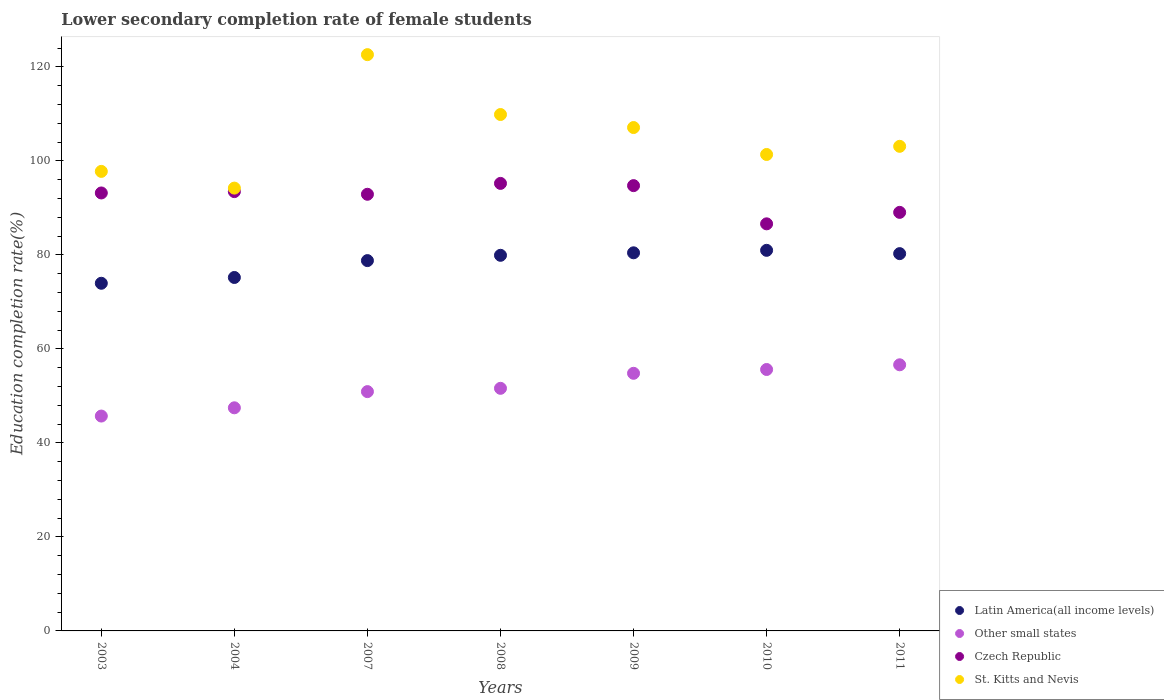What is the lower secondary completion rate of female students in Latin America(all income levels) in 2010?
Your answer should be compact. 80.98. Across all years, what is the maximum lower secondary completion rate of female students in Czech Republic?
Offer a terse response. 95.22. Across all years, what is the minimum lower secondary completion rate of female students in St. Kitts and Nevis?
Your answer should be compact. 94.22. In which year was the lower secondary completion rate of female students in St. Kitts and Nevis maximum?
Offer a very short reply. 2007. In which year was the lower secondary completion rate of female students in Czech Republic minimum?
Offer a terse response. 2010. What is the total lower secondary completion rate of female students in Latin America(all income levels) in the graph?
Your answer should be very brief. 549.61. What is the difference between the lower secondary completion rate of female students in Other small states in 2004 and that in 2011?
Your answer should be very brief. -9.15. What is the difference between the lower secondary completion rate of female students in Other small states in 2007 and the lower secondary completion rate of female students in St. Kitts and Nevis in 2009?
Your answer should be very brief. -56.19. What is the average lower secondary completion rate of female students in Latin America(all income levels) per year?
Offer a very short reply. 78.52. In the year 2003, what is the difference between the lower secondary completion rate of female students in Other small states and lower secondary completion rate of female students in St. Kitts and Nevis?
Your answer should be very brief. -52.06. What is the ratio of the lower secondary completion rate of female students in Other small states in 2004 to that in 2009?
Your answer should be very brief. 0.87. Is the lower secondary completion rate of female students in Czech Republic in 2003 less than that in 2011?
Offer a very short reply. No. Is the difference between the lower secondary completion rate of female students in Other small states in 2007 and 2010 greater than the difference between the lower secondary completion rate of female students in St. Kitts and Nevis in 2007 and 2010?
Offer a very short reply. No. What is the difference between the highest and the second highest lower secondary completion rate of female students in St. Kitts and Nevis?
Give a very brief answer. 12.74. What is the difference between the highest and the lowest lower secondary completion rate of female students in Czech Republic?
Make the answer very short. 8.6. In how many years, is the lower secondary completion rate of female students in St. Kitts and Nevis greater than the average lower secondary completion rate of female students in St. Kitts and Nevis taken over all years?
Provide a short and direct response. 3. Is it the case that in every year, the sum of the lower secondary completion rate of female students in St. Kitts and Nevis and lower secondary completion rate of female students in Latin America(all income levels)  is greater than the sum of lower secondary completion rate of female students in Other small states and lower secondary completion rate of female students in Czech Republic?
Your response must be concise. No. Does the lower secondary completion rate of female students in Other small states monotonically increase over the years?
Offer a terse response. Yes. Is the lower secondary completion rate of female students in Other small states strictly less than the lower secondary completion rate of female students in St. Kitts and Nevis over the years?
Keep it short and to the point. Yes. How many dotlines are there?
Offer a terse response. 4. Are the values on the major ticks of Y-axis written in scientific E-notation?
Give a very brief answer. No. Does the graph contain grids?
Your response must be concise. No. How many legend labels are there?
Provide a succinct answer. 4. What is the title of the graph?
Your answer should be very brief. Lower secondary completion rate of female students. Does "Ghana" appear as one of the legend labels in the graph?
Your response must be concise. No. What is the label or title of the Y-axis?
Provide a short and direct response. Education completion rate(%). What is the Education completion rate(%) in Latin America(all income levels) in 2003?
Make the answer very short. 73.97. What is the Education completion rate(%) in Other small states in 2003?
Your answer should be compact. 45.72. What is the Education completion rate(%) in Czech Republic in 2003?
Your response must be concise. 93.19. What is the Education completion rate(%) in St. Kitts and Nevis in 2003?
Offer a very short reply. 97.78. What is the Education completion rate(%) in Latin America(all income levels) in 2004?
Your response must be concise. 75.2. What is the Education completion rate(%) of Other small states in 2004?
Your answer should be compact. 47.47. What is the Education completion rate(%) in Czech Republic in 2004?
Provide a short and direct response. 93.48. What is the Education completion rate(%) of St. Kitts and Nevis in 2004?
Your response must be concise. 94.22. What is the Education completion rate(%) in Latin America(all income levels) in 2007?
Give a very brief answer. 78.8. What is the Education completion rate(%) in Other small states in 2007?
Keep it short and to the point. 50.92. What is the Education completion rate(%) in Czech Republic in 2007?
Make the answer very short. 92.91. What is the Education completion rate(%) of St. Kitts and Nevis in 2007?
Give a very brief answer. 122.62. What is the Education completion rate(%) of Latin America(all income levels) in 2008?
Provide a short and direct response. 79.92. What is the Education completion rate(%) in Other small states in 2008?
Your response must be concise. 51.62. What is the Education completion rate(%) in Czech Republic in 2008?
Give a very brief answer. 95.22. What is the Education completion rate(%) of St. Kitts and Nevis in 2008?
Keep it short and to the point. 109.88. What is the Education completion rate(%) of Latin America(all income levels) in 2009?
Offer a very short reply. 80.45. What is the Education completion rate(%) in Other small states in 2009?
Make the answer very short. 54.82. What is the Education completion rate(%) in Czech Republic in 2009?
Offer a very short reply. 94.75. What is the Education completion rate(%) in St. Kitts and Nevis in 2009?
Your answer should be very brief. 107.11. What is the Education completion rate(%) of Latin America(all income levels) in 2010?
Ensure brevity in your answer.  80.98. What is the Education completion rate(%) of Other small states in 2010?
Make the answer very short. 55.63. What is the Education completion rate(%) in Czech Republic in 2010?
Offer a very short reply. 86.62. What is the Education completion rate(%) of St. Kitts and Nevis in 2010?
Your answer should be very brief. 101.38. What is the Education completion rate(%) in Latin America(all income levels) in 2011?
Your answer should be very brief. 80.28. What is the Education completion rate(%) of Other small states in 2011?
Offer a very short reply. 56.63. What is the Education completion rate(%) in Czech Republic in 2011?
Provide a succinct answer. 89.06. What is the Education completion rate(%) in St. Kitts and Nevis in 2011?
Ensure brevity in your answer.  103.11. Across all years, what is the maximum Education completion rate(%) in Latin America(all income levels)?
Your answer should be very brief. 80.98. Across all years, what is the maximum Education completion rate(%) of Other small states?
Offer a very short reply. 56.63. Across all years, what is the maximum Education completion rate(%) of Czech Republic?
Offer a very short reply. 95.22. Across all years, what is the maximum Education completion rate(%) of St. Kitts and Nevis?
Give a very brief answer. 122.62. Across all years, what is the minimum Education completion rate(%) of Latin America(all income levels)?
Keep it short and to the point. 73.97. Across all years, what is the minimum Education completion rate(%) in Other small states?
Offer a terse response. 45.72. Across all years, what is the minimum Education completion rate(%) of Czech Republic?
Provide a succinct answer. 86.62. Across all years, what is the minimum Education completion rate(%) of St. Kitts and Nevis?
Provide a succinct answer. 94.22. What is the total Education completion rate(%) in Latin America(all income levels) in the graph?
Provide a short and direct response. 549.61. What is the total Education completion rate(%) in Other small states in the graph?
Give a very brief answer. 362.8. What is the total Education completion rate(%) of Czech Republic in the graph?
Provide a short and direct response. 645.22. What is the total Education completion rate(%) of St. Kitts and Nevis in the graph?
Provide a succinct answer. 736.09. What is the difference between the Education completion rate(%) of Latin America(all income levels) in 2003 and that in 2004?
Offer a terse response. -1.23. What is the difference between the Education completion rate(%) in Other small states in 2003 and that in 2004?
Make the answer very short. -1.76. What is the difference between the Education completion rate(%) of Czech Republic in 2003 and that in 2004?
Your answer should be compact. -0.29. What is the difference between the Education completion rate(%) in St. Kitts and Nevis in 2003 and that in 2004?
Your answer should be compact. 3.56. What is the difference between the Education completion rate(%) of Latin America(all income levels) in 2003 and that in 2007?
Make the answer very short. -4.82. What is the difference between the Education completion rate(%) in Other small states in 2003 and that in 2007?
Your answer should be compact. -5.2. What is the difference between the Education completion rate(%) in Czech Republic in 2003 and that in 2007?
Keep it short and to the point. 0.28. What is the difference between the Education completion rate(%) in St. Kitts and Nevis in 2003 and that in 2007?
Your answer should be very brief. -24.84. What is the difference between the Education completion rate(%) of Latin America(all income levels) in 2003 and that in 2008?
Offer a terse response. -5.95. What is the difference between the Education completion rate(%) in Other small states in 2003 and that in 2008?
Make the answer very short. -5.9. What is the difference between the Education completion rate(%) of Czech Republic in 2003 and that in 2008?
Offer a very short reply. -2.03. What is the difference between the Education completion rate(%) of St. Kitts and Nevis in 2003 and that in 2008?
Your answer should be very brief. -12.1. What is the difference between the Education completion rate(%) of Latin America(all income levels) in 2003 and that in 2009?
Provide a succinct answer. -6.48. What is the difference between the Education completion rate(%) of Other small states in 2003 and that in 2009?
Your answer should be compact. -9.1. What is the difference between the Education completion rate(%) in Czech Republic in 2003 and that in 2009?
Provide a short and direct response. -1.56. What is the difference between the Education completion rate(%) in St. Kitts and Nevis in 2003 and that in 2009?
Ensure brevity in your answer.  -9.33. What is the difference between the Education completion rate(%) in Latin America(all income levels) in 2003 and that in 2010?
Your response must be concise. -7.01. What is the difference between the Education completion rate(%) in Other small states in 2003 and that in 2010?
Your response must be concise. -9.91. What is the difference between the Education completion rate(%) of Czech Republic in 2003 and that in 2010?
Provide a short and direct response. 6.57. What is the difference between the Education completion rate(%) of St. Kitts and Nevis in 2003 and that in 2010?
Provide a short and direct response. -3.6. What is the difference between the Education completion rate(%) in Latin America(all income levels) in 2003 and that in 2011?
Offer a terse response. -6.31. What is the difference between the Education completion rate(%) of Other small states in 2003 and that in 2011?
Give a very brief answer. -10.91. What is the difference between the Education completion rate(%) of Czech Republic in 2003 and that in 2011?
Provide a short and direct response. 4.13. What is the difference between the Education completion rate(%) of St. Kitts and Nevis in 2003 and that in 2011?
Provide a short and direct response. -5.33. What is the difference between the Education completion rate(%) of Latin America(all income levels) in 2004 and that in 2007?
Offer a terse response. -3.59. What is the difference between the Education completion rate(%) in Other small states in 2004 and that in 2007?
Give a very brief answer. -3.45. What is the difference between the Education completion rate(%) in Czech Republic in 2004 and that in 2007?
Offer a very short reply. 0.57. What is the difference between the Education completion rate(%) of St. Kitts and Nevis in 2004 and that in 2007?
Make the answer very short. -28.4. What is the difference between the Education completion rate(%) of Latin America(all income levels) in 2004 and that in 2008?
Your response must be concise. -4.72. What is the difference between the Education completion rate(%) in Other small states in 2004 and that in 2008?
Your answer should be very brief. -4.15. What is the difference between the Education completion rate(%) of Czech Republic in 2004 and that in 2008?
Provide a short and direct response. -1.75. What is the difference between the Education completion rate(%) of St. Kitts and Nevis in 2004 and that in 2008?
Ensure brevity in your answer.  -15.66. What is the difference between the Education completion rate(%) of Latin America(all income levels) in 2004 and that in 2009?
Offer a terse response. -5.25. What is the difference between the Education completion rate(%) of Other small states in 2004 and that in 2009?
Keep it short and to the point. -7.34. What is the difference between the Education completion rate(%) of Czech Republic in 2004 and that in 2009?
Ensure brevity in your answer.  -1.27. What is the difference between the Education completion rate(%) in St. Kitts and Nevis in 2004 and that in 2009?
Provide a short and direct response. -12.89. What is the difference between the Education completion rate(%) in Latin America(all income levels) in 2004 and that in 2010?
Offer a very short reply. -5.78. What is the difference between the Education completion rate(%) in Other small states in 2004 and that in 2010?
Give a very brief answer. -8.15. What is the difference between the Education completion rate(%) in Czech Republic in 2004 and that in 2010?
Your answer should be very brief. 6.86. What is the difference between the Education completion rate(%) of St. Kitts and Nevis in 2004 and that in 2010?
Ensure brevity in your answer.  -7.15. What is the difference between the Education completion rate(%) of Latin America(all income levels) in 2004 and that in 2011?
Provide a succinct answer. -5.08. What is the difference between the Education completion rate(%) of Other small states in 2004 and that in 2011?
Offer a terse response. -9.15. What is the difference between the Education completion rate(%) of Czech Republic in 2004 and that in 2011?
Provide a succinct answer. 4.42. What is the difference between the Education completion rate(%) in St. Kitts and Nevis in 2004 and that in 2011?
Your response must be concise. -8.89. What is the difference between the Education completion rate(%) in Latin America(all income levels) in 2007 and that in 2008?
Keep it short and to the point. -1.13. What is the difference between the Education completion rate(%) of Other small states in 2007 and that in 2008?
Ensure brevity in your answer.  -0.7. What is the difference between the Education completion rate(%) of Czech Republic in 2007 and that in 2008?
Your answer should be compact. -2.32. What is the difference between the Education completion rate(%) in St. Kitts and Nevis in 2007 and that in 2008?
Provide a succinct answer. 12.74. What is the difference between the Education completion rate(%) of Latin America(all income levels) in 2007 and that in 2009?
Give a very brief answer. -1.66. What is the difference between the Education completion rate(%) in Other small states in 2007 and that in 2009?
Make the answer very short. -3.9. What is the difference between the Education completion rate(%) of Czech Republic in 2007 and that in 2009?
Give a very brief answer. -1.84. What is the difference between the Education completion rate(%) of St. Kitts and Nevis in 2007 and that in 2009?
Keep it short and to the point. 15.51. What is the difference between the Education completion rate(%) in Latin America(all income levels) in 2007 and that in 2010?
Provide a short and direct response. -2.19. What is the difference between the Education completion rate(%) of Other small states in 2007 and that in 2010?
Provide a short and direct response. -4.71. What is the difference between the Education completion rate(%) in Czech Republic in 2007 and that in 2010?
Your answer should be compact. 6.29. What is the difference between the Education completion rate(%) in St. Kitts and Nevis in 2007 and that in 2010?
Provide a short and direct response. 21.24. What is the difference between the Education completion rate(%) in Latin America(all income levels) in 2007 and that in 2011?
Offer a very short reply. -1.48. What is the difference between the Education completion rate(%) in Other small states in 2007 and that in 2011?
Your response must be concise. -5.71. What is the difference between the Education completion rate(%) in Czech Republic in 2007 and that in 2011?
Offer a very short reply. 3.85. What is the difference between the Education completion rate(%) of St. Kitts and Nevis in 2007 and that in 2011?
Your response must be concise. 19.51. What is the difference between the Education completion rate(%) in Latin America(all income levels) in 2008 and that in 2009?
Ensure brevity in your answer.  -0.53. What is the difference between the Education completion rate(%) of Other small states in 2008 and that in 2009?
Provide a short and direct response. -3.2. What is the difference between the Education completion rate(%) in Czech Republic in 2008 and that in 2009?
Provide a short and direct response. 0.47. What is the difference between the Education completion rate(%) of St. Kitts and Nevis in 2008 and that in 2009?
Your answer should be very brief. 2.77. What is the difference between the Education completion rate(%) in Latin America(all income levels) in 2008 and that in 2010?
Your answer should be compact. -1.06. What is the difference between the Education completion rate(%) in Other small states in 2008 and that in 2010?
Your response must be concise. -4.01. What is the difference between the Education completion rate(%) in Czech Republic in 2008 and that in 2010?
Provide a succinct answer. 8.6. What is the difference between the Education completion rate(%) in St. Kitts and Nevis in 2008 and that in 2010?
Ensure brevity in your answer.  8.5. What is the difference between the Education completion rate(%) of Latin America(all income levels) in 2008 and that in 2011?
Give a very brief answer. -0.36. What is the difference between the Education completion rate(%) in Other small states in 2008 and that in 2011?
Ensure brevity in your answer.  -5.01. What is the difference between the Education completion rate(%) in Czech Republic in 2008 and that in 2011?
Your response must be concise. 6.16. What is the difference between the Education completion rate(%) of St. Kitts and Nevis in 2008 and that in 2011?
Offer a very short reply. 6.77. What is the difference between the Education completion rate(%) of Latin America(all income levels) in 2009 and that in 2010?
Your response must be concise. -0.53. What is the difference between the Education completion rate(%) of Other small states in 2009 and that in 2010?
Provide a succinct answer. -0.81. What is the difference between the Education completion rate(%) of Czech Republic in 2009 and that in 2010?
Provide a succinct answer. 8.13. What is the difference between the Education completion rate(%) of St. Kitts and Nevis in 2009 and that in 2010?
Your response must be concise. 5.73. What is the difference between the Education completion rate(%) of Latin America(all income levels) in 2009 and that in 2011?
Make the answer very short. 0.17. What is the difference between the Education completion rate(%) of Other small states in 2009 and that in 2011?
Provide a succinct answer. -1.81. What is the difference between the Education completion rate(%) of Czech Republic in 2009 and that in 2011?
Your answer should be compact. 5.69. What is the difference between the Education completion rate(%) in St. Kitts and Nevis in 2009 and that in 2011?
Your answer should be compact. 4. What is the difference between the Education completion rate(%) in Latin America(all income levels) in 2010 and that in 2011?
Provide a succinct answer. 0.7. What is the difference between the Education completion rate(%) of Other small states in 2010 and that in 2011?
Your answer should be very brief. -1. What is the difference between the Education completion rate(%) in Czech Republic in 2010 and that in 2011?
Offer a terse response. -2.44. What is the difference between the Education completion rate(%) in St. Kitts and Nevis in 2010 and that in 2011?
Offer a terse response. -1.74. What is the difference between the Education completion rate(%) of Latin America(all income levels) in 2003 and the Education completion rate(%) of Other small states in 2004?
Make the answer very short. 26.5. What is the difference between the Education completion rate(%) of Latin America(all income levels) in 2003 and the Education completion rate(%) of Czech Republic in 2004?
Offer a terse response. -19.5. What is the difference between the Education completion rate(%) of Latin America(all income levels) in 2003 and the Education completion rate(%) of St. Kitts and Nevis in 2004?
Ensure brevity in your answer.  -20.25. What is the difference between the Education completion rate(%) in Other small states in 2003 and the Education completion rate(%) in Czech Republic in 2004?
Give a very brief answer. -47.76. What is the difference between the Education completion rate(%) of Other small states in 2003 and the Education completion rate(%) of St. Kitts and Nevis in 2004?
Your answer should be very brief. -48.5. What is the difference between the Education completion rate(%) of Czech Republic in 2003 and the Education completion rate(%) of St. Kitts and Nevis in 2004?
Your answer should be very brief. -1.03. What is the difference between the Education completion rate(%) of Latin America(all income levels) in 2003 and the Education completion rate(%) of Other small states in 2007?
Offer a very short reply. 23.05. What is the difference between the Education completion rate(%) in Latin America(all income levels) in 2003 and the Education completion rate(%) in Czech Republic in 2007?
Your answer should be compact. -18.94. What is the difference between the Education completion rate(%) of Latin America(all income levels) in 2003 and the Education completion rate(%) of St. Kitts and Nevis in 2007?
Offer a very short reply. -48.65. What is the difference between the Education completion rate(%) of Other small states in 2003 and the Education completion rate(%) of Czech Republic in 2007?
Give a very brief answer. -47.19. What is the difference between the Education completion rate(%) of Other small states in 2003 and the Education completion rate(%) of St. Kitts and Nevis in 2007?
Your answer should be very brief. -76.9. What is the difference between the Education completion rate(%) in Czech Republic in 2003 and the Education completion rate(%) in St. Kitts and Nevis in 2007?
Keep it short and to the point. -29.43. What is the difference between the Education completion rate(%) of Latin America(all income levels) in 2003 and the Education completion rate(%) of Other small states in 2008?
Your answer should be compact. 22.35. What is the difference between the Education completion rate(%) in Latin America(all income levels) in 2003 and the Education completion rate(%) in Czech Republic in 2008?
Offer a very short reply. -21.25. What is the difference between the Education completion rate(%) of Latin America(all income levels) in 2003 and the Education completion rate(%) of St. Kitts and Nevis in 2008?
Give a very brief answer. -35.91. What is the difference between the Education completion rate(%) in Other small states in 2003 and the Education completion rate(%) in Czech Republic in 2008?
Keep it short and to the point. -49.5. What is the difference between the Education completion rate(%) in Other small states in 2003 and the Education completion rate(%) in St. Kitts and Nevis in 2008?
Provide a short and direct response. -64.16. What is the difference between the Education completion rate(%) in Czech Republic in 2003 and the Education completion rate(%) in St. Kitts and Nevis in 2008?
Ensure brevity in your answer.  -16.69. What is the difference between the Education completion rate(%) of Latin America(all income levels) in 2003 and the Education completion rate(%) of Other small states in 2009?
Provide a succinct answer. 19.16. What is the difference between the Education completion rate(%) in Latin America(all income levels) in 2003 and the Education completion rate(%) in Czech Republic in 2009?
Offer a very short reply. -20.78. What is the difference between the Education completion rate(%) of Latin America(all income levels) in 2003 and the Education completion rate(%) of St. Kitts and Nevis in 2009?
Your answer should be very brief. -33.14. What is the difference between the Education completion rate(%) of Other small states in 2003 and the Education completion rate(%) of Czech Republic in 2009?
Offer a very short reply. -49.03. What is the difference between the Education completion rate(%) of Other small states in 2003 and the Education completion rate(%) of St. Kitts and Nevis in 2009?
Provide a succinct answer. -61.39. What is the difference between the Education completion rate(%) of Czech Republic in 2003 and the Education completion rate(%) of St. Kitts and Nevis in 2009?
Make the answer very short. -13.92. What is the difference between the Education completion rate(%) of Latin America(all income levels) in 2003 and the Education completion rate(%) of Other small states in 2010?
Keep it short and to the point. 18.35. What is the difference between the Education completion rate(%) in Latin America(all income levels) in 2003 and the Education completion rate(%) in Czech Republic in 2010?
Offer a terse response. -12.65. What is the difference between the Education completion rate(%) of Latin America(all income levels) in 2003 and the Education completion rate(%) of St. Kitts and Nevis in 2010?
Your response must be concise. -27.4. What is the difference between the Education completion rate(%) in Other small states in 2003 and the Education completion rate(%) in Czech Republic in 2010?
Ensure brevity in your answer.  -40.9. What is the difference between the Education completion rate(%) of Other small states in 2003 and the Education completion rate(%) of St. Kitts and Nevis in 2010?
Ensure brevity in your answer.  -55.66. What is the difference between the Education completion rate(%) of Czech Republic in 2003 and the Education completion rate(%) of St. Kitts and Nevis in 2010?
Make the answer very short. -8.19. What is the difference between the Education completion rate(%) of Latin America(all income levels) in 2003 and the Education completion rate(%) of Other small states in 2011?
Ensure brevity in your answer.  17.35. What is the difference between the Education completion rate(%) in Latin America(all income levels) in 2003 and the Education completion rate(%) in Czech Republic in 2011?
Your answer should be compact. -15.09. What is the difference between the Education completion rate(%) of Latin America(all income levels) in 2003 and the Education completion rate(%) of St. Kitts and Nevis in 2011?
Give a very brief answer. -29.14. What is the difference between the Education completion rate(%) of Other small states in 2003 and the Education completion rate(%) of Czech Republic in 2011?
Your answer should be very brief. -43.34. What is the difference between the Education completion rate(%) of Other small states in 2003 and the Education completion rate(%) of St. Kitts and Nevis in 2011?
Offer a terse response. -57.39. What is the difference between the Education completion rate(%) of Czech Republic in 2003 and the Education completion rate(%) of St. Kitts and Nevis in 2011?
Your answer should be compact. -9.92. What is the difference between the Education completion rate(%) in Latin America(all income levels) in 2004 and the Education completion rate(%) in Other small states in 2007?
Ensure brevity in your answer.  24.28. What is the difference between the Education completion rate(%) of Latin America(all income levels) in 2004 and the Education completion rate(%) of Czech Republic in 2007?
Provide a succinct answer. -17.7. What is the difference between the Education completion rate(%) in Latin America(all income levels) in 2004 and the Education completion rate(%) in St. Kitts and Nevis in 2007?
Keep it short and to the point. -47.41. What is the difference between the Education completion rate(%) of Other small states in 2004 and the Education completion rate(%) of Czech Republic in 2007?
Give a very brief answer. -45.43. What is the difference between the Education completion rate(%) in Other small states in 2004 and the Education completion rate(%) in St. Kitts and Nevis in 2007?
Your response must be concise. -75.15. What is the difference between the Education completion rate(%) in Czech Republic in 2004 and the Education completion rate(%) in St. Kitts and Nevis in 2007?
Provide a succinct answer. -29.14. What is the difference between the Education completion rate(%) of Latin America(all income levels) in 2004 and the Education completion rate(%) of Other small states in 2008?
Your answer should be very brief. 23.58. What is the difference between the Education completion rate(%) in Latin America(all income levels) in 2004 and the Education completion rate(%) in Czech Republic in 2008?
Offer a very short reply. -20.02. What is the difference between the Education completion rate(%) of Latin America(all income levels) in 2004 and the Education completion rate(%) of St. Kitts and Nevis in 2008?
Give a very brief answer. -34.67. What is the difference between the Education completion rate(%) of Other small states in 2004 and the Education completion rate(%) of Czech Republic in 2008?
Keep it short and to the point. -47.75. What is the difference between the Education completion rate(%) of Other small states in 2004 and the Education completion rate(%) of St. Kitts and Nevis in 2008?
Offer a terse response. -62.41. What is the difference between the Education completion rate(%) in Czech Republic in 2004 and the Education completion rate(%) in St. Kitts and Nevis in 2008?
Ensure brevity in your answer.  -16.4. What is the difference between the Education completion rate(%) in Latin America(all income levels) in 2004 and the Education completion rate(%) in Other small states in 2009?
Offer a very short reply. 20.39. What is the difference between the Education completion rate(%) of Latin America(all income levels) in 2004 and the Education completion rate(%) of Czech Republic in 2009?
Offer a very short reply. -19.54. What is the difference between the Education completion rate(%) in Latin America(all income levels) in 2004 and the Education completion rate(%) in St. Kitts and Nevis in 2009?
Provide a succinct answer. -31.9. What is the difference between the Education completion rate(%) in Other small states in 2004 and the Education completion rate(%) in Czech Republic in 2009?
Offer a terse response. -47.27. What is the difference between the Education completion rate(%) of Other small states in 2004 and the Education completion rate(%) of St. Kitts and Nevis in 2009?
Offer a very short reply. -59.64. What is the difference between the Education completion rate(%) of Czech Republic in 2004 and the Education completion rate(%) of St. Kitts and Nevis in 2009?
Ensure brevity in your answer.  -13.63. What is the difference between the Education completion rate(%) in Latin America(all income levels) in 2004 and the Education completion rate(%) in Other small states in 2010?
Provide a succinct answer. 19.58. What is the difference between the Education completion rate(%) of Latin America(all income levels) in 2004 and the Education completion rate(%) of Czech Republic in 2010?
Provide a short and direct response. -11.41. What is the difference between the Education completion rate(%) of Latin America(all income levels) in 2004 and the Education completion rate(%) of St. Kitts and Nevis in 2010?
Make the answer very short. -26.17. What is the difference between the Education completion rate(%) in Other small states in 2004 and the Education completion rate(%) in Czech Republic in 2010?
Make the answer very short. -39.15. What is the difference between the Education completion rate(%) in Other small states in 2004 and the Education completion rate(%) in St. Kitts and Nevis in 2010?
Make the answer very short. -53.9. What is the difference between the Education completion rate(%) in Czech Republic in 2004 and the Education completion rate(%) in St. Kitts and Nevis in 2010?
Your answer should be very brief. -7.9. What is the difference between the Education completion rate(%) in Latin America(all income levels) in 2004 and the Education completion rate(%) in Other small states in 2011?
Provide a succinct answer. 18.58. What is the difference between the Education completion rate(%) in Latin America(all income levels) in 2004 and the Education completion rate(%) in Czech Republic in 2011?
Offer a terse response. -13.85. What is the difference between the Education completion rate(%) in Latin America(all income levels) in 2004 and the Education completion rate(%) in St. Kitts and Nevis in 2011?
Your answer should be compact. -27.91. What is the difference between the Education completion rate(%) in Other small states in 2004 and the Education completion rate(%) in Czech Republic in 2011?
Your answer should be compact. -41.59. What is the difference between the Education completion rate(%) of Other small states in 2004 and the Education completion rate(%) of St. Kitts and Nevis in 2011?
Your answer should be very brief. -55.64. What is the difference between the Education completion rate(%) in Czech Republic in 2004 and the Education completion rate(%) in St. Kitts and Nevis in 2011?
Ensure brevity in your answer.  -9.64. What is the difference between the Education completion rate(%) in Latin America(all income levels) in 2007 and the Education completion rate(%) in Other small states in 2008?
Give a very brief answer. 27.18. What is the difference between the Education completion rate(%) in Latin America(all income levels) in 2007 and the Education completion rate(%) in Czech Republic in 2008?
Your answer should be compact. -16.43. What is the difference between the Education completion rate(%) in Latin America(all income levels) in 2007 and the Education completion rate(%) in St. Kitts and Nevis in 2008?
Keep it short and to the point. -31.08. What is the difference between the Education completion rate(%) of Other small states in 2007 and the Education completion rate(%) of Czech Republic in 2008?
Keep it short and to the point. -44.3. What is the difference between the Education completion rate(%) in Other small states in 2007 and the Education completion rate(%) in St. Kitts and Nevis in 2008?
Provide a succinct answer. -58.96. What is the difference between the Education completion rate(%) of Czech Republic in 2007 and the Education completion rate(%) of St. Kitts and Nevis in 2008?
Make the answer very short. -16.97. What is the difference between the Education completion rate(%) of Latin America(all income levels) in 2007 and the Education completion rate(%) of Other small states in 2009?
Your response must be concise. 23.98. What is the difference between the Education completion rate(%) of Latin America(all income levels) in 2007 and the Education completion rate(%) of Czech Republic in 2009?
Make the answer very short. -15.95. What is the difference between the Education completion rate(%) in Latin America(all income levels) in 2007 and the Education completion rate(%) in St. Kitts and Nevis in 2009?
Ensure brevity in your answer.  -28.31. What is the difference between the Education completion rate(%) of Other small states in 2007 and the Education completion rate(%) of Czech Republic in 2009?
Your response must be concise. -43.83. What is the difference between the Education completion rate(%) of Other small states in 2007 and the Education completion rate(%) of St. Kitts and Nevis in 2009?
Provide a succinct answer. -56.19. What is the difference between the Education completion rate(%) in Czech Republic in 2007 and the Education completion rate(%) in St. Kitts and Nevis in 2009?
Offer a very short reply. -14.2. What is the difference between the Education completion rate(%) of Latin America(all income levels) in 2007 and the Education completion rate(%) of Other small states in 2010?
Keep it short and to the point. 23.17. What is the difference between the Education completion rate(%) of Latin America(all income levels) in 2007 and the Education completion rate(%) of Czech Republic in 2010?
Provide a short and direct response. -7.82. What is the difference between the Education completion rate(%) in Latin America(all income levels) in 2007 and the Education completion rate(%) in St. Kitts and Nevis in 2010?
Provide a short and direct response. -22.58. What is the difference between the Education completion rate(%) of Other small states in 2007 and the Education completion rate(%) of Czech Republic in 2010?
Your answer should be very brief. -35.7. What is the difference between the Education completion rate(%) in Other small states in 2007 and the Education completion rate(%) in St. Kitts and Nevis in 2010?
Provide a short and direct response. -50.46. What is the difference between the Education completion rate(%) of Czech Republic in 2007 and the Education completion rate(%) of St. Kitts and Nevis in 2010?
Your response must be concise. -8.47. What is the difference between the Education completion rate(%) of Latin America(all income levels) in 2007 and the Education completion rate(%) of Other small states in 2011?
Your answer should be very brief. 22.17. What is the difference between the Education completion rate(%) of Latin America(all income levels) in 2007 and the Education completion rate(%) of Czech Republic in 2011?
Ensure brevity in your answer.  -10.26. What is the difference between the Education completion rate(%) of Latin America(all income levels) in 2007 and the Education completion rate(%) of St. Kitts and Nevis in 2011?
Your answer should be compact. -24.32. What is the difference between the Education completion rate(%) of Other small states in 2007 and the Education completion rate(%) of Czech Republic in 2011?
Give a very brief answer. -38.14. What is the difference between the Education completion rate(%) of Other small states in 2007 and the Education completion rate(%) of St. Kitts and Nevis in 2011?
Give a very brief answer. -52.19. What is the difference between the Education completion rate(%) of Czech Republic in 2007 and the Education completion rate(%) of St. Kitts and Nevis in 2011?
Keep it short and to the point. -10.2. What is the difference between the Education completion rate(%) in Latin America(all income levels) in 2008 and the Education completion rate(%) in Other small states in 2009?
Offer a terse response. 25.11. What is the difference between the Education completion rate(%) of Latin America(all income levels) in 2008 and the Education completion rate(%) of Czech Republic in 2009?
Your answer should be very brief. -14.82. What is the difference between the Education completion rate(%) of Latin America(all income levels) in 2008 and the Education completion rate(%) of St. Kitts and Nevis in 2009?
Provide a succinct answer. -27.19. What is the difference between the Education completion rate(%) of Other small states in 2008 and the Education completion rate(%) of Czech Republic in 2009?
Offer a very short reply. -43.13. What is the difference between the Education completion rate(%) of Other small states in 2008 and the Education completion rate(%) of St. Kitts and Nevis in 2009?
Give a very brief answer. -55.49. What is the difference between the Education completion rate(%) in Czech Republic in 2008 and the Education completion rate(%) in St. Kitts and Nevis in 2009?
Your answer should be compact. -11.89. What is the difference between the Education completion rate(%) in Latin America(all income levels) in 2008 and the Education completion rate(%) in Other small states in 2010?
Provide a short and direct response. 24.3. What is the difference between the Education completion rate(%) of Latin America(all income levels) in 2008 and the Education completion rate(%) of Czech Republic in 2010?
Your answer should be compact. -6.7. What is the difference between the Education completion rate(%) in Latin America(all income levels) in 2008 and the Education completion rate(%) in St. Kitts and Nevis in 2010?
Keep it short and to the point. -21.45. What is the difference between the Education completion rate(%) in Other small states in 2008 and the Education completion rate(%) in Czech Republic in 2010?
Offer a terse response. -35. What is the difference between the Education completion rate(%) of Other small states in 2008 and the Education completion rate(%) of St. Kitts and Nevis in 2010?
Make the answer very short. -49.76. What is the difference between the Education completion rate(%) in Czech Republic in 2008 and the Education completion rate(%) in St. Kitts and Nevis in 2010?
Your answer should be very brief. -6.15. What is the difference between the Education completion rate(%) of Latin America(all income levels) in 2008 and the Education completion rate(%) of Other small states in 2011?
Offer a very short reply. 23.3. What is the difference between the Education completion rate(%) in Latin America(all income levels) in 2008 and the Education completion rate(%) in Czech Republic in 2011?
Your answer should be very brief. -9.14. What is the difference between the Education completion rate(%) of Latin America(all income levels) in 2008 and the Education completion rate(%) of St. Kitts and Nevis in 2011?
Your response must be concise. -23.19. What is the difference between the Education completion rate(%) in Other small states in 2008 and the Education completion rate(%) in Czech Republic in 2011?
Ensure brevity in your answer.  -37.44. What is the difference between the Education completion rate(%) in Other small states in 2008 and the Education completion rate(%) in St. Kitts and Nevis in 2011?
Give a very brief answer. -51.49. What is the difference between the Education completion rate(%) of Czech Republic in 2008 and the Education completion rate(%) of St. Kitts and Nevis in 2011?
Make the answer very short. -7.89. What is the difference between the Education completion rate(%) of Latin America(all income levels) in 2009 and the Education completion rate(%) of Other small states in 2010?
Ensure brevity in your answer.  24.83. What is the difference between the Education completion rate(%) in Latin America(all income levels) in 2009 and the Education completion rate(%) in Czech Republic in 2010?
Your response must be concise. -6.17. What is the difference between the Education completion rate(%) in Latin America(all income levels) in 2009 and the Education completion rate(%) in St. Kitts and Nevis in 2010?
Your answer should be very brief. -20.92. What is the difference between the Education completion rate(%) in Other small states in 2009 and the Education completion rate(%) in Czech Republic in 2010?
Provide a short and direct response. -31.8. What is the difference between the Education completion rate(%) in Other small states in 2009 and the Education completion rate(%) in St. Kitts and Nevis in 2010?
Your answer should be very brief. -46.56. What is the difference between the Education completion rate(%) of Czech Republic in 2009 and the Education completion rate(%) of St. Kitts and Nevis in 2010?
Provide a short and direct response. -6.63. What is the difference between the Education completion rate(%) in Latin America(all income levels) in 2009 and the Education completion rate(%) in Other small states in 2011?
Your response must be concise. 23.83. What is the difference between the Education completion rate(%) in Latin America(all income levels) in 2009 and the Education completion rate(%) in Czech Republic in 2011?
Provide a short and direct response. -8.61. What is the difference between the Education completion rate(%) in Latin America(all income levels) in 2009 and the Education completion rate(%) in St. Kitts and Nevis in 2011?
Make the answer very short. -22.66. What is the difference between the Education completion rate(%) of Other small states in 2009 and the Education completion rate(%) of Czech Republic in 2011?
Your answer should be very brief. -34.24. What is the difference between the Education completion rate(%) of Other small states in 2009 and the Education completion rate(%) of St. Kitts and Nevis in 2011?
Give a very brief answer. -48.29. What is the difference between the Education completion rate(%) of Czech Republic in 2009 and the Education completion rate(%) of St. Kitts and Nevis in 2011?
Provide a short and direct response. -8.36. What is the difference between the Education completion rate(%) of Latin America(all income levels) in 2010 and the Education completion rate(%) of Other small states in 2011?
Offer a terse response. 24.36. What is the difference between the Education completion rate(%) in Latin America(all income levels) in 2010 and the Education completion rate(%) in Czech Republic in 2011?
Provide a succinct answer. -8.08. What is the difference between the Education completion rate(%) of Latin America(all income levels) in 2010 and the Education completion rate(%) of St. Kitts and Nevis in 2011?
Offer a very short reply. -22.13. What is the difference between the Education completion rate(%) of Other small states in 2010 and the Education completion rate(%) of Czech Republic in 2011?
Provide a short and direct response. -33.43. What is the difference between the Education completion rate(%) of Other small states in 2010 and the Education completion rate(%) of St. Kitts and Nevis in 2011?
Ensure brevity in your answer.  -47.48. What is the difference between the Education completion rate(%) in Czech Republic in 2010 and the Education completion rate(%) in St. Kitts and Nevis in 2011?
Keep it short and to the point. -16.49. What is the average Education completion rate(%) of Latin America(all income levels) per year?
Your response must be concise. 78.52. What is the average Education completion rate(%) in Other small states per year?
Keep it short and to the point. 51.83. What is the average Education completion rate(%) in Czech Republic per year?
Make the answer very short. 92.17. What is the average Education completion rate(%) of St. Kitts and Nevis per year?
Keep it short and to the point. 105.16. In the year 2003, what is the difference between the Education completion rate(%) of Latin America(all income levels) and Education completion rate(%) of Other small states?
Provide a short and direct response. 28.25. In the year 2003, what is the difference between the Education completion rate(%) of Latin America(all income levels) and Education completion rate(%) of Czech Republic?
Your answer should be compact. -19.22. In the year 2003, what is the difference between the Education completion rate(%) in Latin America(all income levels) and Education completion rate(%) in St. Kitts and Nevis?
Provide a succinct answer. -23.81. In the year 2003, what is the difference between the Education completion rate(%) of Other small states and Education completion rate(%) of Czech Republic?
Keep it short and to the point. -47.47. In the year 2003, what is the difference between the Education completion rate(%) of Other small states and Education completion rate(%) of St. Kitts and Nevis?
Make the answer very short. -52.06. In the year 2003, what is the difference between the Education completion rate(%) of Czech Republic and Education completion rate(%) of St. Kitts and Nevis?
Provide a short and direct response. -4.59. In the year 2004, what is the difference between the Education completion rate(%) of Latin America(all income levels) and Education completion rate(%) of Other small states?
Offer a terse response. 27.73. In the year 2004, what is the difference between the Education completion rate(%) of Latin America(all income levels) and Education completion rate(%) of Czech Republic?
Offer a terse response. -18.27. In the year 2004, what is the difference between the Education completion rate(%) in Latin America(all income levels) and Education completion rate(%) in St. Kitts and Nevis?
Your answer should be compact. -19.02. In the year 2004, what is the difference between the Education completion rate(%) in Other small states and Education completion rate(%) in Czech Republic?
Offer a terse response. -46. In the year 2004, what is the difference between the Education completion rate(%) in Other small states and Education completion rate(%) in St. Kitts and Nevis?
Your answer should be very brief. -46.75. In the year 2004, what is the difference between the Education completion rate(%) of Czech Republic and Education completion rate(%) of St. Kitts and Nevis?
Keep it short and to the point. -0.75. In the year 2007, what is the difference between the Education completion rate(%) in Latin America(all income levels) and Education completion rate(%) in Other small states?
Provide a succinct answer. 27.88. In the year 2007, what is the difference between the Education completion rate(%) in Latin America(all income levels) and Education completion rate(%) in Czech Republic?
Offer a very short reply. -14.11. In the year 2007, what is the difference between the Education completion rate(%) in Latin America(all income levels) and Education completion rate(%) in St. Kitts and Nevis?
Give a very brief answer. -43.82. In the year 2007, what is the difference between the Education completion rate(%) of Other small states and Education completion rate(%) of Czech Republic?
Your response must be concise. -41.99. In the year 2007, what is the difference between the Education completion rate(%) in Other small states and Education completion rate(%) in St. Kitts and Nevis?
Offer a very short reply. -71.7. In the year 2007, what is the difference between the Education completion rate(%) of Czech Republic and Education completion rate(%) of St. Kitts and Nevis?
Your response must be concise. -29.71. In the year 2008, what is the difference between the Education completion rate(%) in Latin America(all income levels) and Education completion rate(%) in Other small states?
Keep it short and to the point. 28.3. In the year 2008, what is the difference between the Education completion rate(%) of Latin America(all income levels) and Education completion rate(%) of Czech Republic?
Offer a terse response. -15.3. In the year 2008, what is the difference between the Education completion rate(%) of Latin America(all income levels) and Education completion rate(%) of St. Kitts and Nevis?
Provide a short and direct response. -29.96. In the year 2008, what is the difference between the Education completion rate(%) of Other small states and Education completion rate(%) of Czech Republic?
Your answer should be very brief. -43.6. In the year 2008, what is the difference between the Education completion rate(%) in Other small states and Education completion rate(%) in St. Kitts and Nevis?
Provide a succinct answer. -58.26. In the year 2008, what is the difference between the Education completion rate(%) of Czech Republic and Education completion rate(%) of St. Kitts and Nevis?
Your answer should be compact. -14.66. In the year 2009, what is the difference between the Education completion rate(%) in Latin America(all income levels) and Education completion rate(%) in Other small states?
Your response must be concise. 25.64. In the year 2009, what is the difference between the Education completion rate(%) in Latin America(all income levels) and Education completion rate(%) in Czech Republic?
Your answer should be very brief. -14.29. In the year 2009, what is the difference between the Education completion rate(%) in Latin America(all income levels) and Education completion rate(%) in St. Kitts and Nevis?
Provide a succinct answer. -26.66. In the year 2009, what is the difference between the Education completion rate(%) of Other small states and Education completion rate(%) of Czech Republic?
Your response must be concise. -39.93. In the year 2009, what is the difference between the Education completion rate(%) in Other small states and Education completion rate(%) in St. Kitts and Nevis?
Offer a very short reply. -52.29. In the year 2009, what is the difference between the Education completion rate(%) of Czech Republic and Education completion rate(%) of St. Kitts and Nevis?
Give a very brief answer. -12.36. In the year 2010, what is the difference between the Education completion rate(%) of Latin America(all income levels) and Education completion rate(%) of Other small states?
Ensure brevity in your answer.  25.36. In the year 2010, what is the difference between the Education completion rate(%) in Latin America(all income levels) and Education completion rate(%) in Czech Republic?
Your answer should be very brief. -5.64. In the year 2010, what is the difference between the Education completion rate(%) of Latin America(all income levels) and Education completion rate(%) of St. Kitts and Nevis?
Give a very brief answer. -20.39. In the year 2010, what is the difference between the Education completion rate(%) in Other small states and Education completion rate(%) in Czech Republic?
Your answer should be very brief. -30.99. In the year 2010, what is the difference between the Education completion rate(%) of Other small states and Education completion rate(%) of St. Kitts and Nevis?
Keep it short and to the point. -45.75. In the year 2010, what is the difference between the Education completion rate(%) in Czech Republic and Education completion rate(%) in St. Kitts and Nevis?
Offer a very short reply. -14.76. In the year 2011, what is the difference between the Education completion rate(%) of Latin America(all income levels) and Education completion rate(%) of Other small states?
Ensure brevity in your answer.  23.65. In the year 2011, what is the difference between the Education completion rate(%) of Latin America(all income levels) and Education completion rate(%) of Czech Republic?
Make the answer very short. -8.78. In the year 2011, what is the difference between the Education completion rate(%) in Latin America(all income levels) and Education completion rate(%) in St. Kitts and Nevis?
Provide a short and direct response. -22.83. In the year 2011, what is the difference between the Education completion rate(%) in Other small states and Education completion rate(%) in Czech Republic?
Provide a succinct answer. -32.43. In the year 2011, what is the difference between the Education completion rate(%) of Other small states and Education completion rate(%) of St. Kitts and Nevis?
Make the answer very short. -46.49. In the year 2011, what is the difference between the Education completion rate(%) of Czech Republic and Education completion rate(%) of St. Kitts and Nevis?
Provide a short and direct response. -14.05. What is the ratio of the Education completion rate(%) of Latin America(all income levels) in 2003 to that in 2004?
Ensure brevity in your answer.  0.98. What is the ratio of the Education completion rate(%) of St. Kitts and Nevis in 2003 to that in 2004?
Make the answer very short. 1.04. What is the ratio of the Education completion rate(%) of Latin America(all income levels) in 2003 to that in 2007?
Make the answer very short. 0.94. What is the ratio of the Education completion rate(%) of Other small states in 2003 to that in 2007?
Give a very brief answer. 0.9. What is the ratio of the Education completion rate(%) in St. Kitts and Nevis in 2003 to that in 2007?
Your response must be concise. 0.8. What is the ratio of the Education completion rate(%) in Latin America(all income levels) in 2003 to that in 2008?
Provide a short and direct response. 0.93. What is the ratio of the Education completion rate(%) of Other small states in 2003 to that in 2008?
Your response must be concise. 0.89. What is the ratio of the Education completion rate(%) in Czech Republic in 2003 to that in 2008?
Offer a terse response. 0.98. What is the ratio of the Education completion rate(%) of St. Kitts and Nevis in 2003 to that in 2008?
Offer a very short reply. 0.89. What is the ratio of the Education completion rate(%) in Latin America(all income levels) in 2003 to that in 2009?
Ensure brevity in your answer.  0.92. What is the ratio of the Education completion rate(%) in Other small states in 2003 to that in 2009?
Offer a terse response. 0.83. What is the ratio of the Education completion rate(%) in Czech Republic in 2003 to that in 2009?
Give a very brief answer. 0.98. What is the ratio of the Education completion rate(%) of St. Kitts and Nevis in 2003 to that in 2009?
Your answer should be very brief. 0.91. What is the ratio of the Education completion rate(%) of Latin America(all income levels) in 2003 to that in 2010?
Provide a succinct answer. 0.91. What is the ratio of the Education completion rate(%) in Other small states in 2003 to that in 2010?
Give a very brief answer. 0.82. What is the ratio of the Education completion rate(%) of Czech Republic in 2003 to that in 2010?
Your response must be concise. 1.08. What is the ratio of the Education completion rate(%) of St. Kitts and Nevis in 2003 to that in 2010?
Ensure brevity in your answer.  0.96. What is the ratio of the Education completion rate(%) of Latin America(all income levels) in 2003 to that in 2011?
Make the answer very short. 0.92. What is the ratio of the Education completion rate(%) in Other small states in 2003 to that in 2011?
Offer a very short reply. 0.81. What is the ratio of the Education completion rate(%) of Czech Republic in 2003 to that in 2011?
Your answer should be compact. 1.05. What is the ratio of the Education completion rate(%) in St. Kitts and Nevis in 2003 to that in 2011?
Provide a succinct answer. 0.95. What is the ratio of the Education completion rate(%) of Latin America(all income levels) in 2004 to that in 2007?
Your answer should be very brief. 0.95. What is the ratio of the Education completion rate(%) of Other small states in 2004 to that in 2007?
Provide a succinct answer. 0.93. What is the ratio of the Education completion rate(%) in Czech Republic in 2004 to that in 2007?
Make the answer very short. 1.01. What is the ratio of the Education completion rate(%) of St. Kitts and Nevis in 2004 to that in 2007?
Your answer should be very brief. 0.77. What is the ratio of the Education completion rate(%) of Latin America(all income levels) in 2004 to that in 2008?
Your response must be concise. 0.94. What is the ratio of the Education completion rate(%) of Other small states in 2004 to that in 2008?
Give a very brief answer. 0.92. What is the ratio of the Education completion rate(%) of Czech Republic in 2004 to that in 2008?
Provide a succinct answer. 0.98. What is the ratio of the Education completion rate(%) of St. Kitts and Nevis in 2004 to that in 2008?
Your answer should be compact. 0.86. What is the ratio of the Education completion rate(%) in Latin America(all income levels) in 2004 to that in 2009?
Provide a succinct answer. 0.93. What is the ratio of the Education completion rate(%) of Other small states in 2004 to that in 2009?
Your response must be concise. 0.87. What is the ratio of the Education completion rate(%) in Czech Republic in 2004 to that in 2009?
Your answer should be very brief. 0.99. What is the ratio of the Education completion rate(%) of St. Kitts and Nevis in 2004 to that in 2009?
Provide a succinct answer. 0.88. What is the ratio of the Education completion rate(%) of Latin America(all income levels) in 2004 to that in 2010?
Offer a very short reply. 0.93. What is the ratio of the Education completion rate(%) in Other small states in 2004 to that in 2010?
Keep it short and to the point. 0.85. What is the ratio of the Education completion rate(%) in Czech Republic in 2004 to that in 2010?
Make the answer very short. 1.08. What is the ratio of the Education completion rate(%) in St. Kitts and Nevis in 2004 to that in 2010?
Provide a succinct answer. 0.93. What is the ratio of the Education completion rate(%) of Latin America(all income levels) in 2004 to that in 2011?
Give a very brief answer. 0.94. What is the ratio of the Education completion rate(%) in Other small states in 2004 to that in 2011?
Provide a short and direct response. 0.84. What is the ratio of the Education completion rate(%) of Czech Republic in 2004 to that in 2011?
Give a very brief answer. 1.05. What is the ratio of the Education completion rate(%) of St. Kitts and Nevis in 2004 to that in 2011?
Give a very brief answer. 0.91. What is the ratio of the Education completion rate(%) in Latin America(all income levels) in 2007 to that in 2008?
Keep it short and to the point. 0.99. What is the ratio of the Education completion rate(%) of Other small states in 2007 to that in 2008?
Ensure brevity in your answer.  0.99. What is the ratio of the Education completion rate(%) in Czech Republic in 2007 to that in 2008?
Offer a very short reply. 0.98. What is the ratio of the Education completion rate(%) in St. Kitts and Nevis in 2007 to that in 2008?
Keep it short and to the point. 1.12. What is the ratio of the Education completion rate(%) of Latin America(all income levels) in 2007 to that in 2009?
Your answer should be compact. 0.98. What is the ratio of the Education completion rate(%) of Other small states in 2007 to that in 2009?
Provide a succinct answer. 0.93. What is the ratio of the Education completion rate(%) in Czech Republic in 2007 to that in 2009?
Make the answer very short. 0.98. What is the ratio of the Education completion rate(%) in St. Kitts and Nevis in 2007 to that in 2009?
Give a very brief answer. 1.14. What is the ratio of the Education completion rate(%) in Other small states in 2007 to that in 2010?
Your answer should be compact. 0.92. What is the ratio of the Education completion rate(%) of Czech Republic in 2007 to that in 2010?
Offer a terse response. 1.07. What is the ratio of the Education completion rate(%) of St. Kitts and Nevis in 2007 to that in 2010?
Offer a terse response. 1.21. What is the ratio of the Education completion rate(%) in Latin America(all income levels) in 2007 to that in 2011?
Your answer should be compact. 0.98. What is the ratio of the Education completion rate(%) of Other small states in 2007 to that in 2011?
Ensure brevity in your answer.  0.9. What is the ratio of the Education completion rate(%) in Czech Republic in 2007 to that in 2011?
Your answer should be very brief. 1.04. What is the ratio of the Education completion rate(%) of St. Kitts and Nevis in 2007 to that in 2011?
Ensure brevity in your answer.  1.19. What is the ratio of the Education completion rate(%) of Other small states in 2008 to that in 2009?
Ensure brevity in your answer.  0.94. What is the ratio of the Education completion rate(%) in Czech Republic in 2008 to that in 2009?
Your answer should be very brief. 1. What is the ratio of the Education completion rate(%) in St. Kitts and Nevis in 2008 to that in 2009?
Give a very brief answer. 1.03. What is the ratio of the Education completion rate(%) of Latin America(all income levels) in 2008 to that in 2010?
Provide a succinct answer. 0.99. What is the ratio of the Education completion rate(%) in Other small states in 2008 to that in 2010?
Make the answer very short. 0.93. What is the ratio of the Education completion rate(%) in Czech Republic in 2008 to that in 2010?
Offer a very short reply. 1.1. What is the ratio of the Education completion rate(%) of St. Kitts and Nevis in 2008 to that in 2010?
Provide a succinct answer. 1.08. What is the ratio of the Education completion rate(%) of Other small states in 2008 to that in 2011?
Offer a terse response. 0.91. What is the ratio of the Education completion rate(%) of Czech Republic in 2008 to that in 2011?
Make the answer very short. 1.07. What is the ratio of the Education completion rate(%) in St. Kitts and Nevis in 2008 to that in 2011?
Keep it short and to the point. 1.07. What is the ratio of the Education completion rate(%) of Latin America(all income levels) in 2009 to that in 2010?
Provide a short and direct response. 0.99. What is the ratio of the Education completion rate(%) in Other small states in 2009 to that in 2010?
Make the answer very short. 0.99. What is the ratio of the Education completion rate(%) in Czech Republic in 2009 to that in 2010?
Offer a terse response. 1.09. What is the ratio of the Education completion rate(%) in St. Kitts and Nevis in 2009 to that in 2010?
Keep it short and to the point. 1.06. What is the ratio of the Education completion rate(%) in Latin America(all income levels) in 2009 to that in 2011?
Offer a terse response. 1. What is the ratio of the Education completion rate(%) in Other small states in 2009 to that in 2011?
Your answer should be compact. 0.97. What is the ratio of the Education completion rate(%) in Czech Republic in 2009 to that in 2011?
Offer a terse response. 1.06. What is the ratio of the Education completion rate(%) of St. Kitts and Nevis in 2009 to that in 2011?
Keep it short and to the point. 1.04. What is the ratio of the Education completion rate(%) in Latin America(all income levels) in 2010 to that in 2011?
Make the answer very short. 1.01. What is the ratio of the Education completion rate(%) in Other small states in 2010 to that in 2011?
Ensure brevity in your answer.  0.98. What is the ratio of the Education completion rate(%) of Czech Republic in 2010 to that in 2011?
Ensure brevity in your answer.  0.97. What is the ratio of the Education completion rate(%) of St. Kitts and Nevis in 2010 to that in 2011?
Provide a succinct answer. 0.98. What is the difference between the highest and the second highest Education completion rate(%) of Latin America(all income levels)?
Provide a short and direct response. 0.53. What is the difference between the highest and the second highest Education completion rate(%) in Czech Republic?
Your response must be concise. 0.47. What is the difference between the highest and the second highest Education completion rate(%) of St. Kitts and Nevis?
Make the answer very short. 12.74. What is the difference between the highest and the lowest Education completion rate(%) of Latin America(all income levels)?
Your answer should be very brief. 7.01. What is the difference between the highest and the lowest Education completion rate(%) in Other small states?
Provide a succinct answer. 10.91. What is the difference between the highest and the lowest Education completion rate(%) of Czech Republic?
Your response must be concise. 8.6. What is the difference between the highest and the lowest Education completion rate(%) in St. Kitts and Nevis?
Provide a succinct answer. 28.4. 